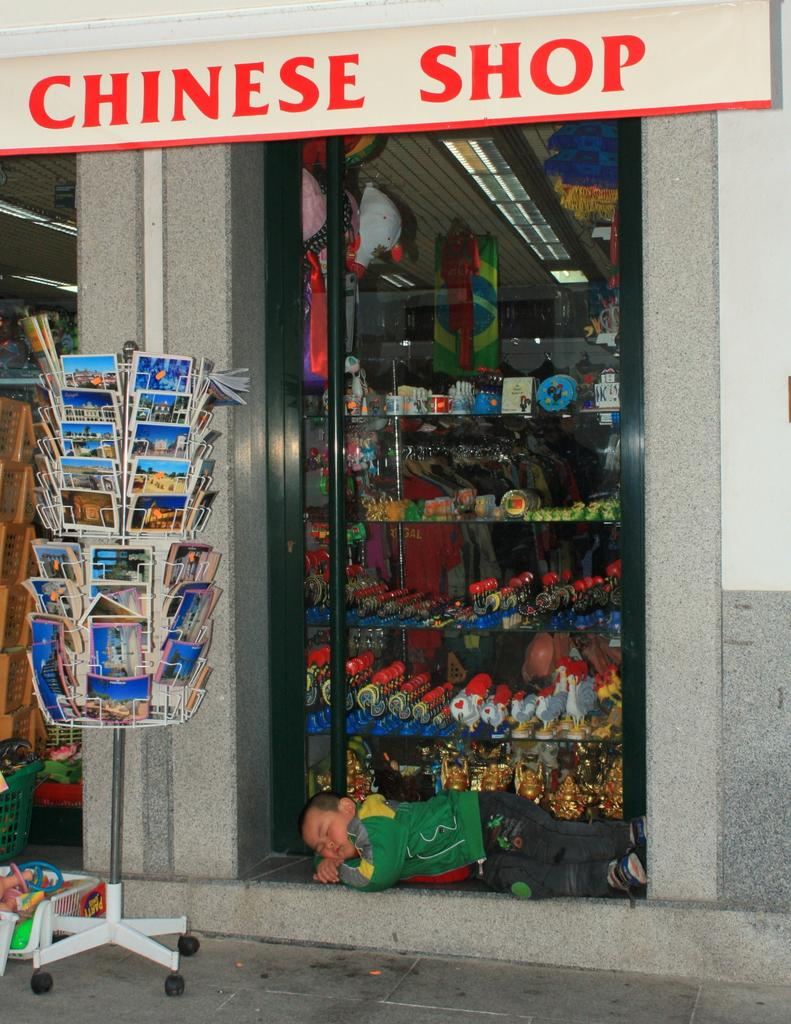Provide a one-sentence caption for the provided image. A Chinese shop sells post cards on a display out front. 